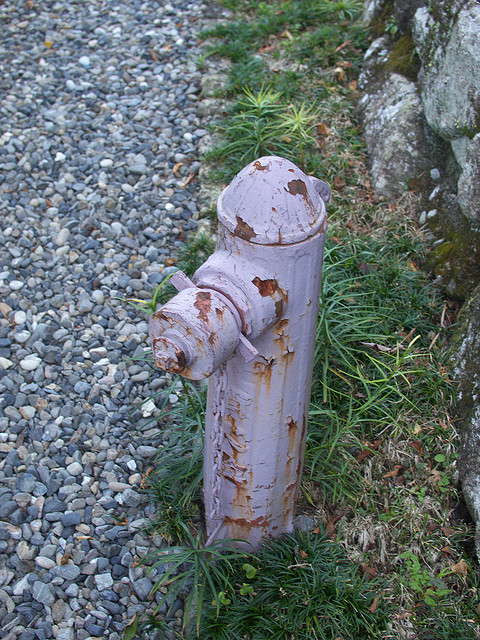How many weeds can you see near the fireplug? It is difficult to provide an exact count as the weeds are mixed in with the grass, but there are several weeds visible at the base of the fireplug. 